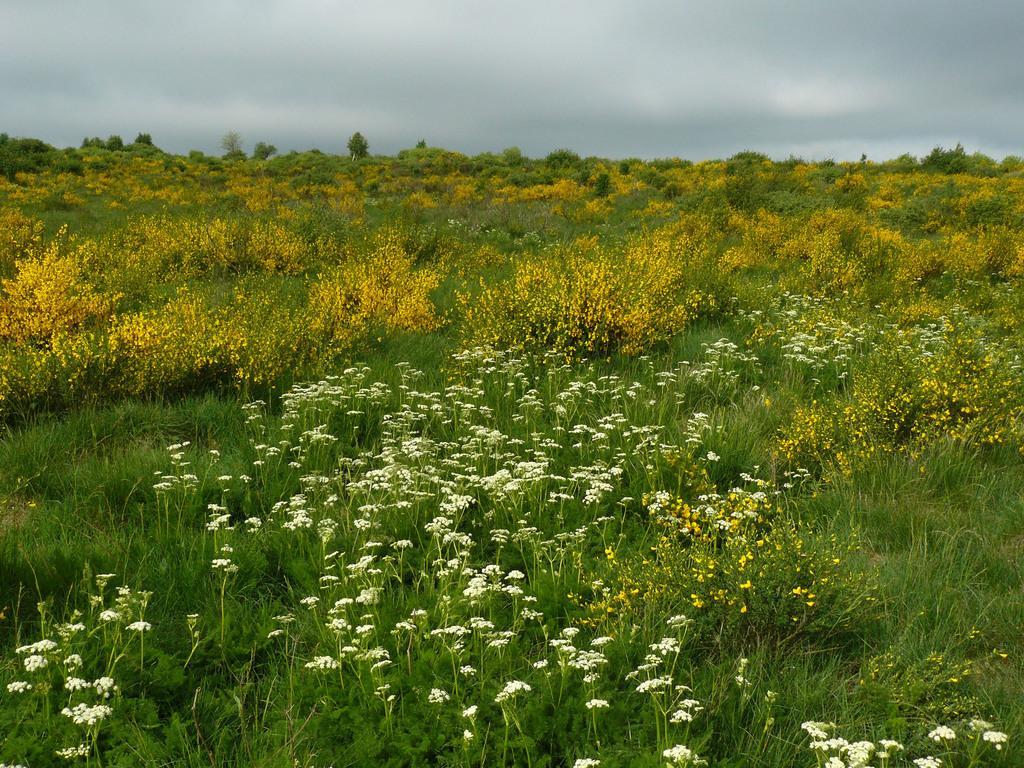Please provide a concise description of this image. In this picture, we can see the grounds with grass, plants, flowers, trees, and the sky with clouds. 